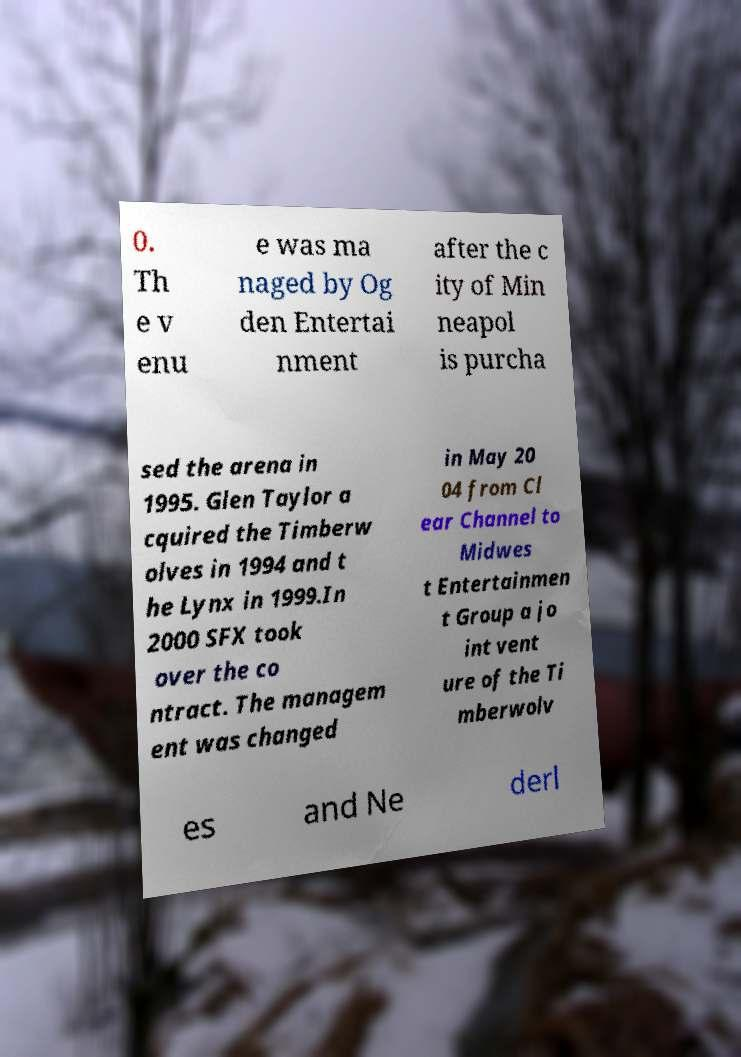Could you extract and type out the text from this image? 0. Th e v enu e was ma naged by Og den Entertai nment after the c ity of Min neapol is purcha sed the arena in 1995. Glen Taylor a cquired the Timberw olves in 1994 and t he Lynx in 1999.In 2000 SFX took over the co ntract. The managem ent was changed in May 20 04 from Cl ear Channel to Midwes t Entertainmen t Group a jo int vent ure of the Ti mberwolv es and Ne derl 